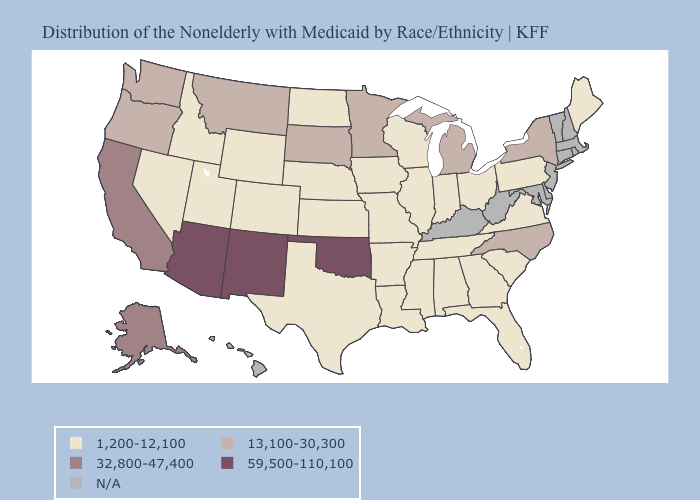What is the highest value in the West ?
Write a very short answer. 59,500-110,100. Name the states that have a value in the range 1,200-12,100?
Give a very brief answer. Alabama, Arkansas, Colorado, Florida, Georgia, Idaho, Illinois, Indiana, Iowa, Kansas, Louisiana, Maine, Mississippi, Missouri, Nebraska, Nevada, North Dakota, Ohio, Pennsylvania, South Carolina, Tennessee, Texas, Utah, Virginia, Wisconsin, Wyoming. Among the states that border Nevada , which have the lowest value?
Answer briefly. Idaho, Utah. Name the states that have a value in the range 32,800-47,400?
Be succinct. Alaska, California. Which states have the lowest value in the USA?
Write a very short answer. Alabama, Arkansas, Colorado, Florida, Georgia, Idaho, Illinois, Indiana, Iowa, Kansas, Louisiana, Maine, Mississippi, Missouri, Nebraska, Nevada, North Dakota, Ohio, Pennsylvania, South Carolina, Tennessee, Texas, Utah, Virginia, Wisconsin, Wyoming. What is the value of West Virginia?
Be succinct. N/A. How many symbols are there in the legend?
Keep it brief. 5. Name the states that have a value in the range 1,200-12,100?
Write a very short answer. Alabama, Arkansas, Colorado, Florida, Georgia, Idaho, Illinois, Indiana, Iowa, Kansas, Louisiana, Maine, Mississippi, Missouri, Nebraska, Nevada, North Dakota, Ohio, Pennsylvania, South Carolina, Tennessee, Texas, Utah, Virginia, Wisconsin, Wyoming. Name the states that have a value in the range 13,100-30,300?
Answer briefly. Michigan, Minnesota, Montana, New York, North Carolina, Oregon, South Dakota, Washington. What is the value of Georgia?
Short answer required. 1,200-12,100. Does the first symbol in the legend represent the smallest category?
Write a very short answer. Yes. Name the states that have a value in the range 32,800-47,400?
Concise answer only. Alaska, California. What is the lowest value in the MidWest?
Answer briefly. 1,200-12,100. 